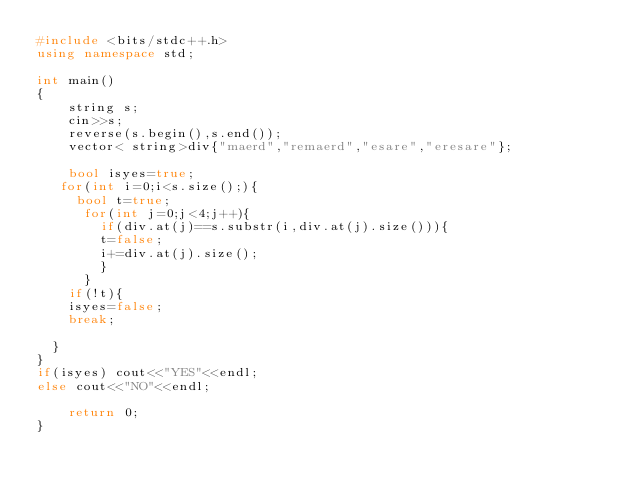Convert code to text. <code><loc_0><loc_0><loc_500><loc_500><_C++_>#include <bits/stdc++.h>
using namespace std;

int main()
{
    string s;
    cin>>s;
    reverse(s.begin(),s.end());
    vector< string>div{"maerd","remaerd","esare","eresare"};
    
    bool isyes=true;
   for(int i=0;i<s.size();){
     bool t=true;
      for(int j=0;j<4;j++){
        if(div.at(j)==s.substr(i,div.at(j).size())){
        t=false;
        i+=div.at(j).size();
        }
      }
    if(!t){
    isyes=false;
    break;
    
  }
}
if(isyes) cout<<"YES"<<endl;
else cout<<"NO"<<endl;
          
    return 0;
}
</code> 